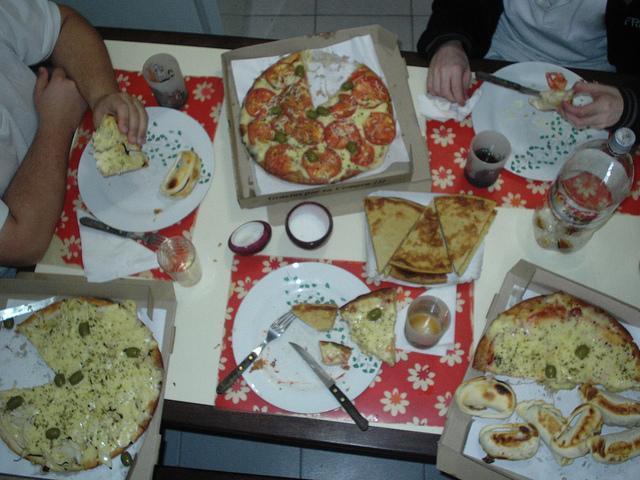How many pizzas are there?
Give a very brief answer. 8. How many people are there?
Give a very brief answer. 2. How many person is wearing orange color t-shirt?
Give a very brief answer. 0. 